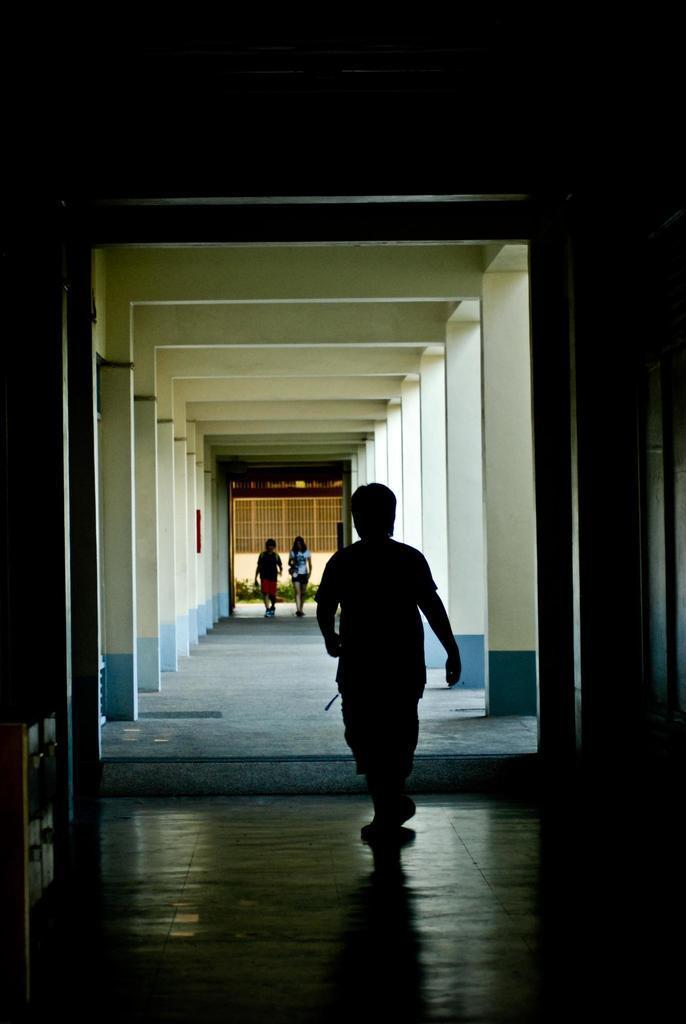Can you describe this image briefly? In this picture we can see three persons are walking, in the background there are some plants and grilles, it is an inside view of a building. 